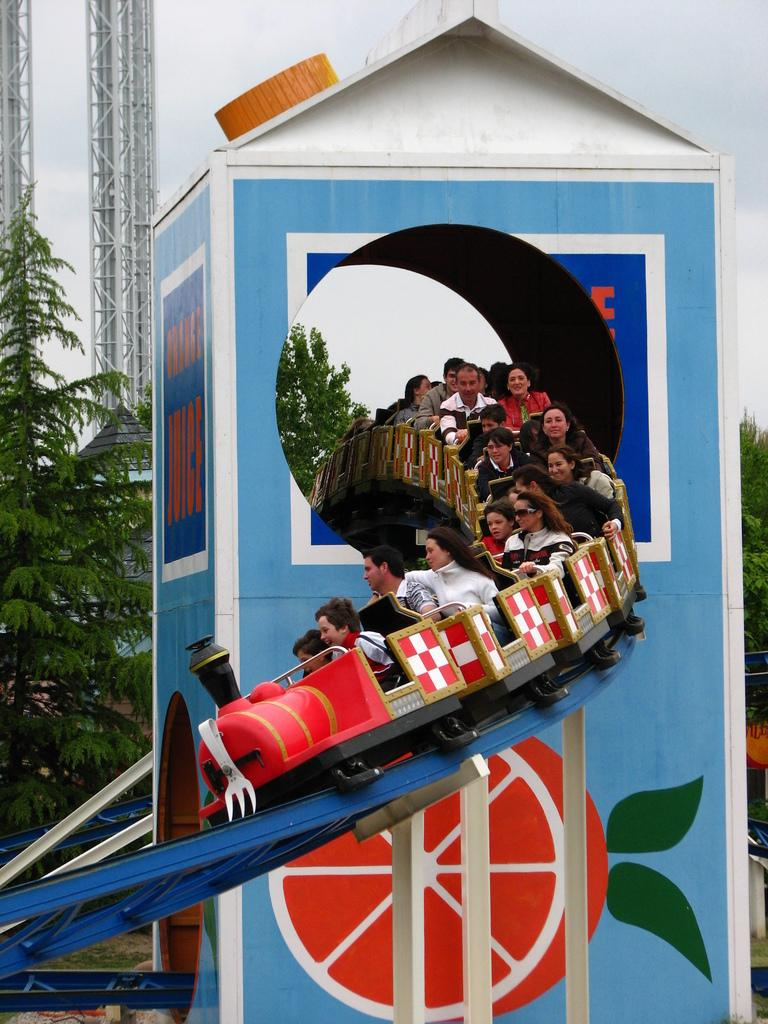What are the people in the image doing? There are people sitting on a toy train in the image. What is unique about the toy train? The toy train is part of a roller coaster ride. What can be seen in the background of the image? There are trees visible in the background of the image. What type of structures are present in the image? There are iron poles in the image. What is the condition of the sky in the image? The sky is clear in the image. What type of tin can be seen being crushed by the toy train in the image? There is no tin present in the image, nor is there any indication of it being crushed by the toy train. Are there any balloons visible in the image? There are no balloons present in the image. 